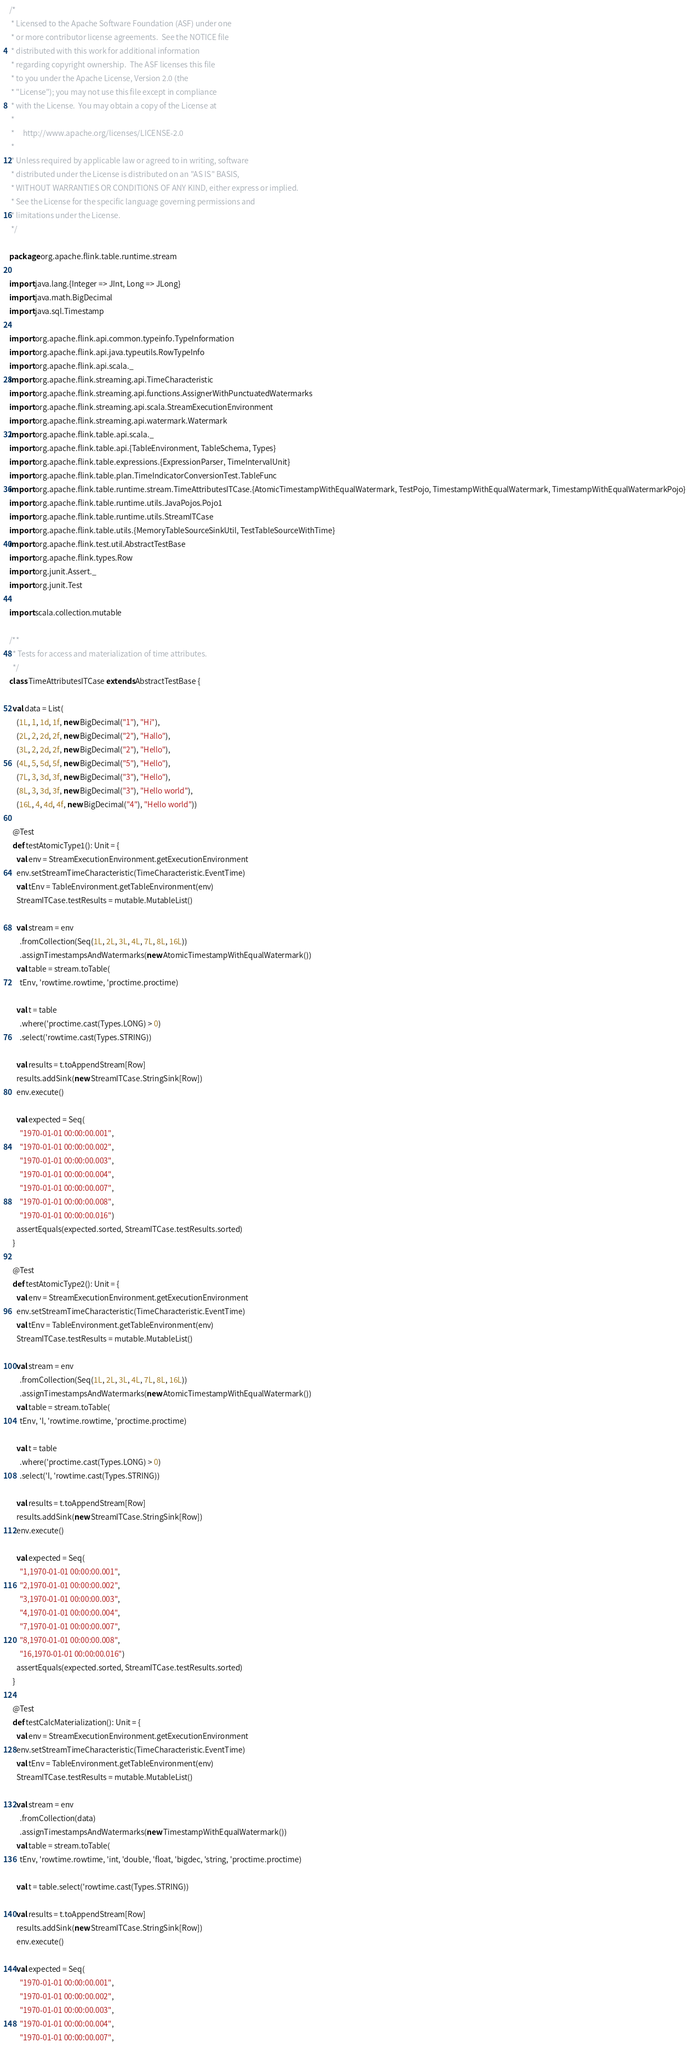<code> <loc_0><loc_0><loc_500><loc_500><_Scala_>/*
 * Licensed to the Apache Software Foundation (ASF) under one
 * or more contributor license agreements.  See the NOTICE file
 * distributed with this work for additional information
 * regarding copyright ownership.  The ASF licenses this file
 * to you under the Apache License, Version 2.0 (the
 * "License"); you may not use this file except in compliance
 * with the License.  You may obtain a copy of the License at
 *
 *     http://www.apache.org/licenses/LICENSE-2.0
 *
 * Unless required by applicable law or agreed to in writing, software
 * distributed under the License is distributed on an "AS IS" BASIS,
 * WITHOUT WARRANTIES OR CONDITIONS OF ANY KIND, either express or implied.
 * See the License for the specific language governing permissions and
 * limitations under the License.
 */

package org.apache.flink.table.runtime.stream

import java.lang.{Integer => JInt, Long => JLong}
import java.math.BigDecimal
import java.sql.Timestamp

import org.apache.flink.api.common.typeinfo.TypeInformation
import org.apache.flink.api.java.typeutils.RowTypeInfo
import org.apache.flink.api.scala._
import org.apache.flink.streaming.api.TimeCharacteristic
import org.apache.flink.streaming.api.functions.AssignerWithPunctuatedWatermarks
import org.apache.flink.streaming.api.scala.StreamExecutionEnvironment
import org.apache.flink.streaming.api.watermark.Watermark
import org.apache.flink.table.api.scala._
import org.apache.flink.table.api.{TableEnvironment, TableSchema, Types}
import org.apache.flink.table.expressions.{ExpressionParser, TimeIntervalUnit}
import org.apache.flink.table.plan.TimeIndicatorConversionTest.TableFunc
import org.apache.flink.table.runtime.stream.TimeAttributesITCase.{AtomicTimestampWithEqualWatermark, TestPojo, TimestampWithEqualWatermark, TimestampWithEqualWatermarkPojo}
import org.apache.flink.table.runtime.utils.JavaPojos.Pojo1
import org.apache.flink.table.runtime.utils.StreamITCase
import org.apache.flink.table.utils.{MemoryTableSourceSinkUtil, TestTableSourceWithTime}
import org.apache.flink.test.util.AbstractTestBase
import org.apache.flink.types.Row
import org.junit.Assert._
import org.junit.Test

import scala.collection.mutable

/**
  * Tests for access and materialization of time attributes.
  */
class TimeAttributesITCase extends AbstractTestBase {

  val data = List(
    (1L, 1, 1d, 1f, new BigDecimal("1"), "Hi"),
    (2L, 2, 2d, 2f, new BigDecimal("2"), "Hallo"),
    (3L, 2, 2d, 2f, new BigDecimal("2"), "Hello"),
    (4L, 5, 5d, 5f, new BigDecimal("5"), "Hello"),
    (7L, 3, 3d, 3f, new BigDecimal("3"), "Hello"),
    (8L, 3, 3d, 3f, new BigDecimal("3"), "Hello world"),
    (16L, 4, 4d, 4f, new BigDecimal("4"), "Hello world"))

  @Test
  def testAtomicType1(): Unit = {
    val env = StreamExecutionEnvironment.getExecutionEnvironment
    env.setStreamTimeCharacteristic(TimeCharacteristic.EventTime)
    val tEnv = TableEnvironment.getTableEnvironment(env)
    StreamITCase.testResults = mutable.MutableList()

    val stream = env
      .fromCollection(Seq(1L, 2L, 3L, 4L, 7L, 8L, 16L))
      .assignTimestampsAndWatermarks(new AtomicTimestampWithEqualWatermark())
    val table = stream.toTable(
      tEnv, 'rowtime.rowtime, 'proctime.proctime)

    val t = table
      .where('proctime.cast(Types.LONG) > 0)
      .select('rowtime.cast(Types.STRING))

    val results = t.toAppendStream[Row]
    results.addSink(new StreamITCase.StringSink[Row])
    env.execute()

    val expected = Seq(
      "1970-01-01 00:00:00.001",
      "1970-01-01 00:00:00.002",
      "1970-01-01 00:00:00.003",
      "1970-01-01 00:00:00.004",
      "1970-01-01 00:00:00.007",
      "1970-01-01 00:00:00.008",
      "1970-01-01 00:00:00.016")
    assertEquals(expected.sorted, StreamITCase.testResults.sorted)
  }

  @Test
  def testAtomicType2(): Unit = {
    val env = StreamExecutionEnvironment.getExecutionEnvironment
    env.setStreamTimeCharacteristic(TimeCharacteristic.EventTime)
    val tEnv = TableEnvironment.getTableEnvironment(env)
    StreamITCase.testResults = mutable.MutableList()

    val stream = env
      .fromCollection(Seq(1L, 2L, 3L, 4L, 7L, 8L, 16L))
      .assignTimestampsAndWatermarks(new AtomicTimestampWithEqualWatermark())
    val table = stream.toTable(
      tEnv, 'l, 'rowtime.rowtime, 'proctime.proctime)

    val t = table
      .where('proctime.cast(Types.LONG) > 0)
      .select('l, 'rowtime.cast(Types.STRING))

    val results = t.toAppendStream[Row]
    results.addSink(new StreamITCase.StringSink[Row])
    env.execute()

    val expected = Seq(
      "1,1970-01-01 00:00:00.001",
      "2,1970-01-01 00:00:00.002",
      "3,1970-01-01 00:00:00.003",
      "4,1970-01-01 00:00:00.004",
      "7,1970-01-01 00:00:00.007",
      "8,1970-01-01 00:00:00.008",
      "16,1970-01-01 00:00:00.016")
    assertEquals(expected.sorted, StreamITCase.testResults.sorted)
  }

  @Test
  def testCalcMaterialization(): Unit = {
    val env = StreamExecutionEnvironment.getExecutionEnvironment
    env.setStreamTimeCharacteristic(TimeCharacteristic.EventTime)
    val tEnv = TableEnvironment.getTableEnvironment(env)
    StreamITCase.testResults = mutable.MutableList()

    val stream = env
      .fromCollection(data)
      .assignTimestampsAndWatermarks(new TimestampWithEqualWatermark())
    val table = stream.toTable(
      tEnv, 'rowtime.rowtime, 'int, 'double, 'float, 'bigdec, 'string, 'proctime.proctime)

    val t = table.select('rowtime.cast(Types.STRING))

    val results = t.toAppendStream[Row]
    results.addSink(new StreamITCase.StringSink[Row])
    env.execute()

    val expected = Seq(
      "1970-01-01 00:00:00.001",
      "1970-01-01 00:00:00.002",
      "1970-01-01 00:00:00.003",
      "1970-01-01 00:00:00.004",
      "1970-01-01 00:00:00.007",</code> 